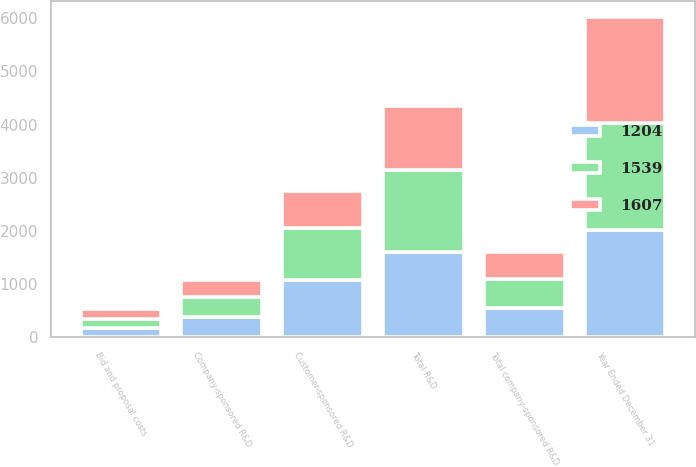<chart> <loc_0><loc_0><loc_500><loc_500><stacked_bar_chart><ecel><fcel>Year Ended December 31<fcel>Company-sponsored R&D<fcel>Bid and proposal costs<fcel>Total company-sponsored R&D<fcel>Customer-sponsored R&D<fcel>Total R&D<nl><fcel>1607<fcel>2010<fcel>325<fcel>183<fcel>508<fcel>696<fcel>1204<nl><fcel>1539<fcel>2011<fcel>372<fcel>173<fcel>545<fcel>994<fcel>1539<nl><fcel>1204<fcel>2012<fcel>374<fcel>170<fcel>544<fcel>1063<fcel>1607<nl></chart> 